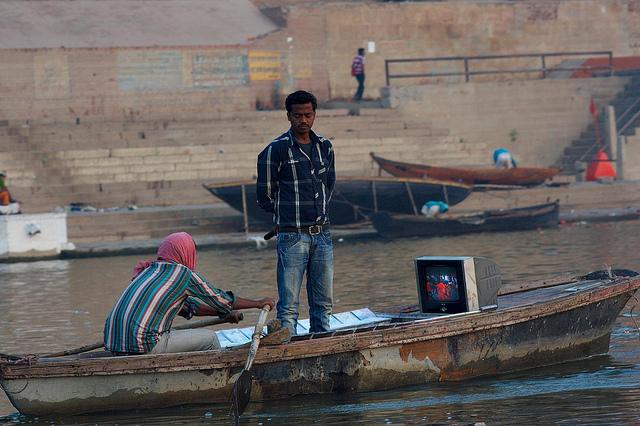What is on the front of the boat?
Keep it brief. Tv. How many boats do you see?
Answer briefly. 4. Which of the people is rowing the boat?
Keep it brief. One sitting. 